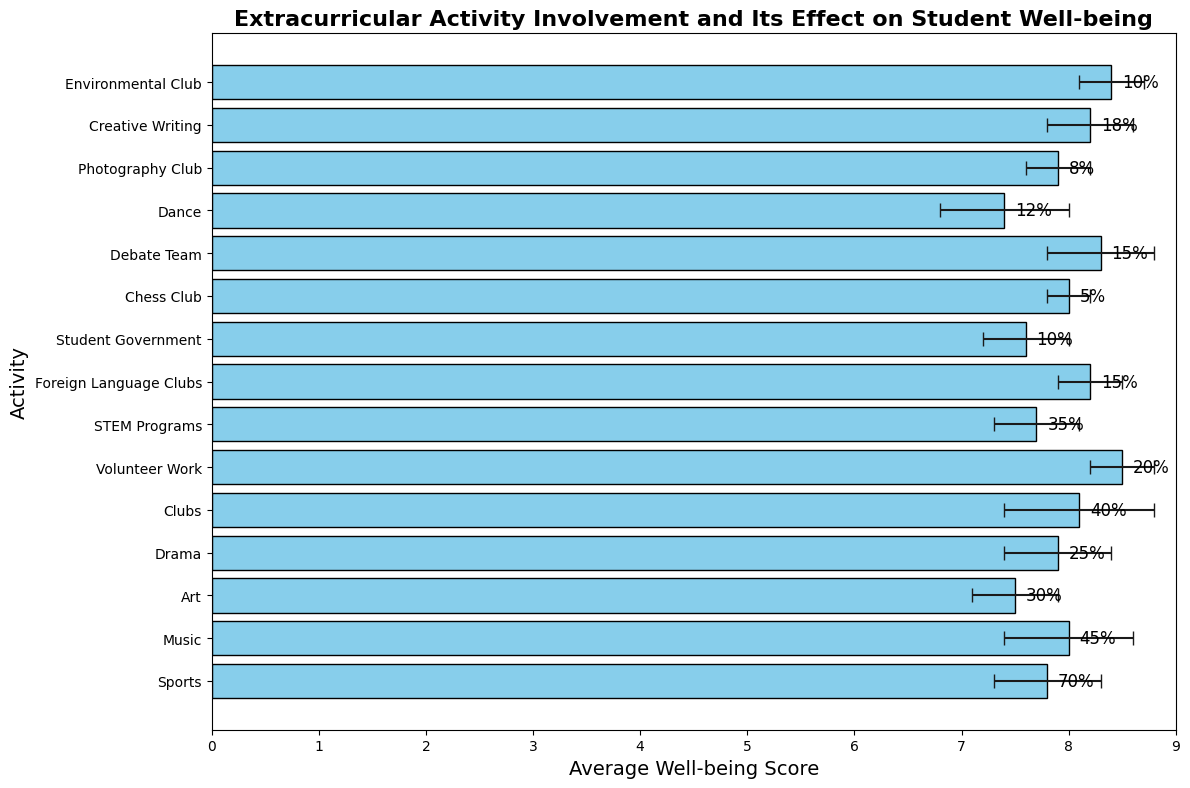Which activity has the highest well-being score? Compare the well-being scores of all activities and identify which one is the highest. Volunteer Work has the highest well-being score of 8.5.
Answer: Volunteer Work Which activity has the lowest participation rate? Compare the participation rates of all activities and identify which one is the lowest. Chess Club has the lowest participation rate of 5%.
Answer: Chess Club What is the difference in well-being score between the highest and lowest scoring activities? Find the highest well-being score (Volunteer Work, 8.5) and the lowest (Dance, 7.4). Calculate the difference: 8.5 - 7.4 = 1.1.
Answer: 1.1 What is the average well-being score of all activities combined? Add the well-being scores of all activities and divide by the number of activities (15). (7.8 + 8.0 + 7.5 + 7.9 + 8.1 + 8.5 + 7.7 + 8.2 + 7.6 + 8.0 + 8.3 + 7.4 + 7.9 + 8.2 + 8.4) / 15 = 122.5 / 15 = 8.17.
Answer: 8.17 Which activity has the widest error bar indicating the highest standard deviation? Observe the length of the error bars and identify which one is the longest. Clubs have the highest standard deviation of 0.7.
Answer: Clubs Which activities have a well-being score higher than 8? Identify activities with a well-being score greater than 8. Music, Clubs, Volunteer Work, Foreign Language Clubs, Creative Writing, Environmental Club, and Debate Team all have scores above 8.
Answer: Music, Clubs, Volunteer Work, Foreign Language Clubs, Creative Writing, Environmental Club, Debate Team How much higher is the well-being score of the Drama activity compared to the Dance activity? Find the well-being scores for Drama (7.9) and Dance (7.4), then subtract: 7.9 - 7.4 = 0.5.
Answer: 0.5 Which activity has the smallest error bar indicating the lowest standard deviation? Observe the length of the error bars and identify which one is the shortest. Chess Club has the smallest standard deviation of 0.2.
Answer: Chess Club Compare the participation rates of Sports and Clubs. Find the participation rates of Sports (70%) and Clubs (40%) and compare them. Sports has a higher participation rate than Clubs.
Answer: Sports How does the participation rate of STEM Programs compare to the average participation rate of all activities? Calculate the average participation rate of all activities. (70 + 45 + 30 + 25 + 40 + 20 + 35 + 15 + 10 + 5 + 15 + 12 + 8 + 18 + 10) / 15 = 358 / 15 = 23.87%. Compare it to the rate of STEM Programs (35%). STEM Programs have a higher participation rate than the average.
Answer: Higher 